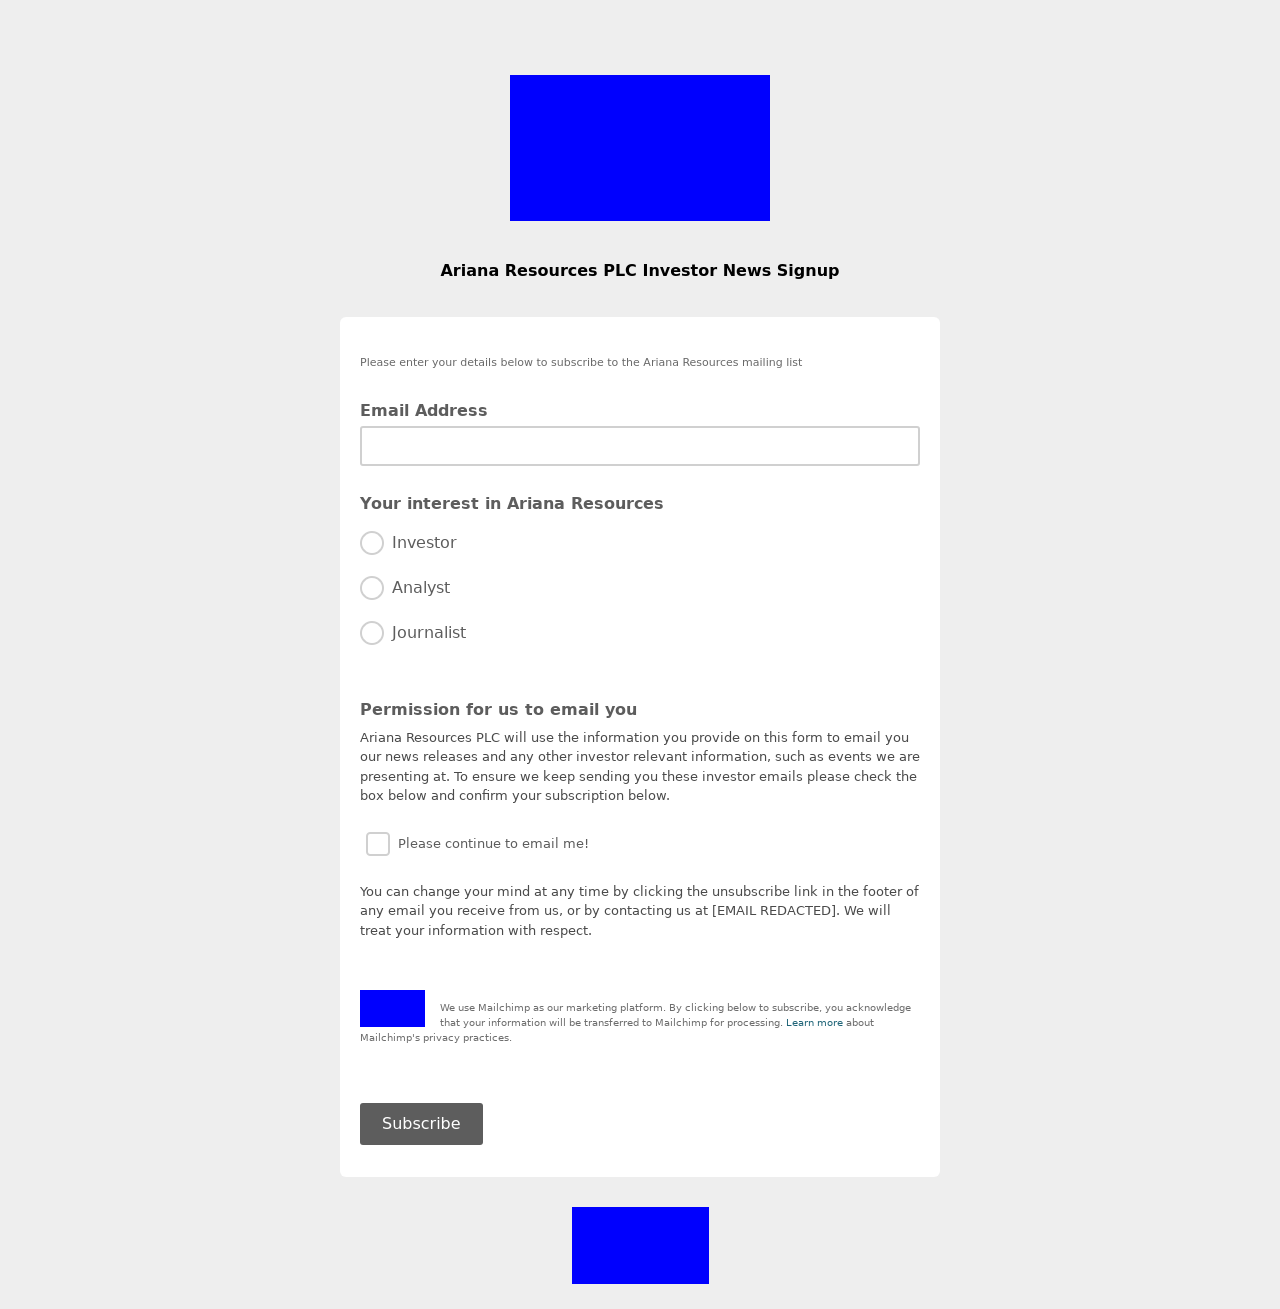Can I customize the design of the form shown in this image to better match my company's branding? Absolutely! The design of the form can be extensively customized using CSS (Cascading Style Sheets). You can modify the colors, fonts, layout, and other visual elements to align with your company's branding. Utilize CSS properties to adjust elements like the background color, font sizes, and button styles. For enhancing user interaction, consider adding hover effects or transitions. If the form adjustments need more dynamic functionalities, JavaScript could also be incorporated for real-time validations or interactive elements. 